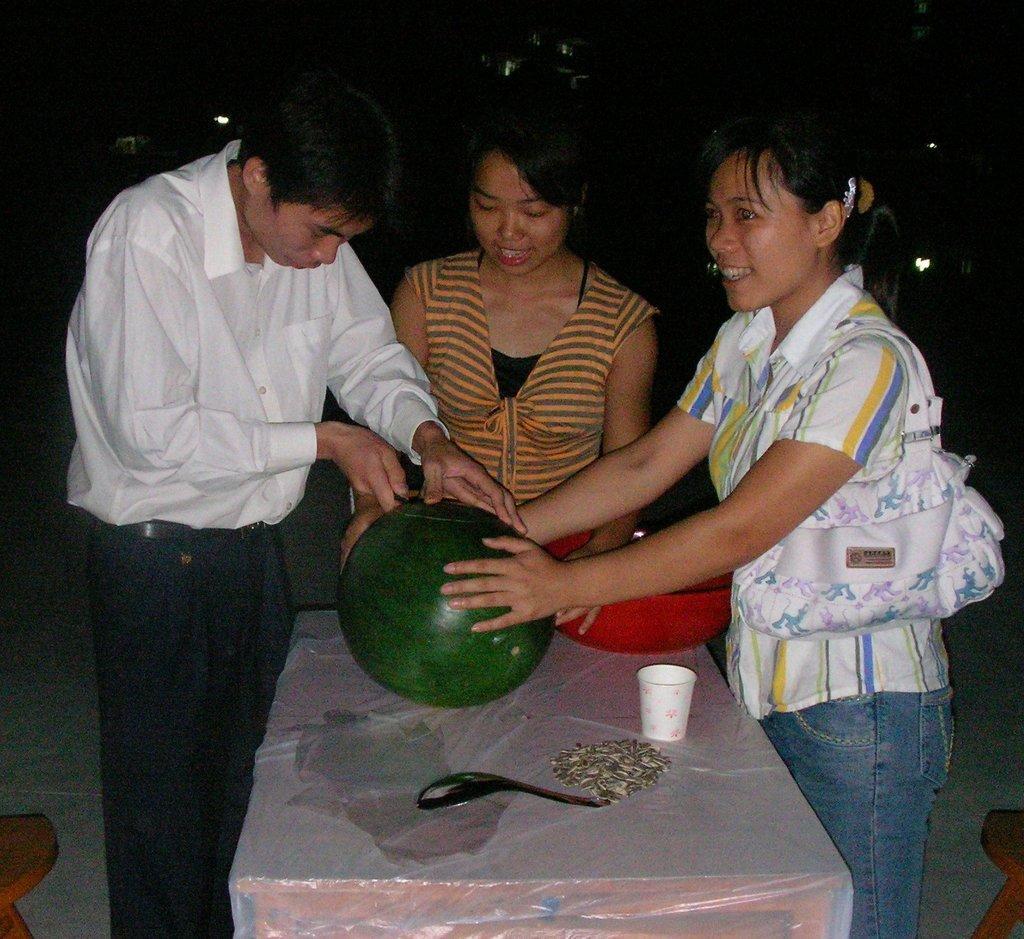How would you summarize this image in a sentence or two? In this picture there are people standing and holding a watermelon and we can see bowl, cup, spoon and objects on the table. In the bottom left and right side of the image we can see wooden objects. In the background of the image it is dark. 